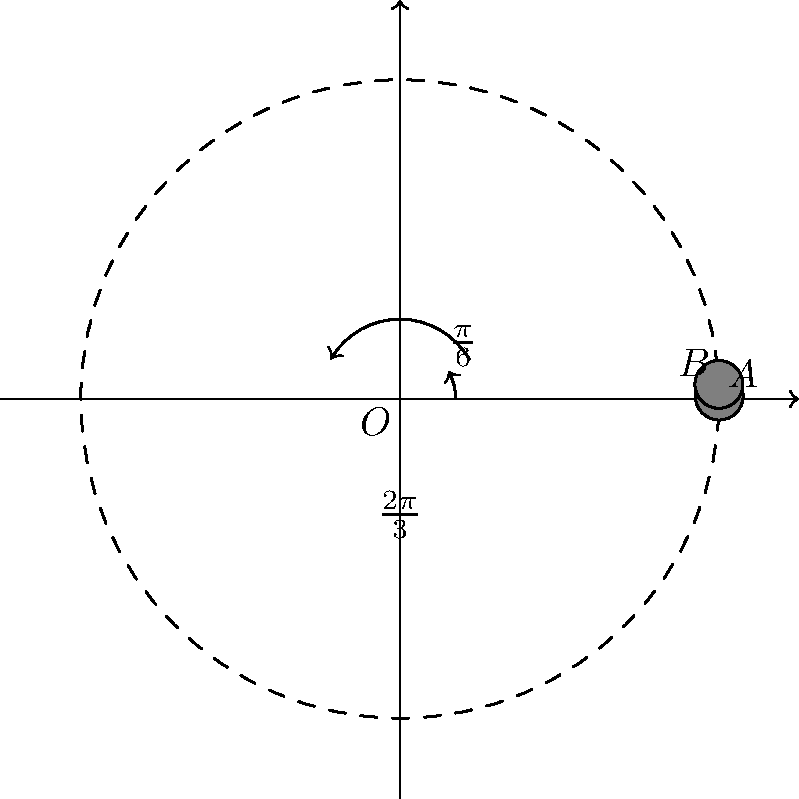In a classic episode of "The Twilight Zone," a circular alien spacecraft is observed orbiting Earth. The spacecraft's path can be modeled using polar coordinates with the Earth at the origin. The craft starts at point $A$ and moves counterclockwise to point $B$. If the initial angle is $\frac{\pi}{6}$ radians and the spacecraft rotates through an angle of $\frac{2\pi}{3}$ radians, what is the final angular position of the spacecraft in radians? Let's approach this step-by-step:

1) The initial position of the spacecraft is at angle $\theta_1 = \frac{\pi}{6}$ radians.

2) The spacecraft rotates through an angle of $\frac{2\pi}{3}$ radians in the counterclockwise direction.

3) To find the final angular position, we need to add the initial angle and the rotation angle:

   $\theta_2 = \theta_1 + \text{rotation angle}$

4) Substituting the values:

   $\theta_2 = \frac{\pi}{6} + \frac{2\pi}{3}$

5) To add these fractions, we need a common denominator. The least common multiple of 6 and 3 is 6, so:

   $\theta_2 = \frac{\pi}{6} + \frac{4\pi}{6}$

6) Now we can add the numerators:

   $\theta_2 = \frac{5\pi}{6}$

Therefore, the final angular position of the spacecraft is $\frac{5\pi}{6}$ radians.
Answer: $\frac{5\pi}{6}$ radians 